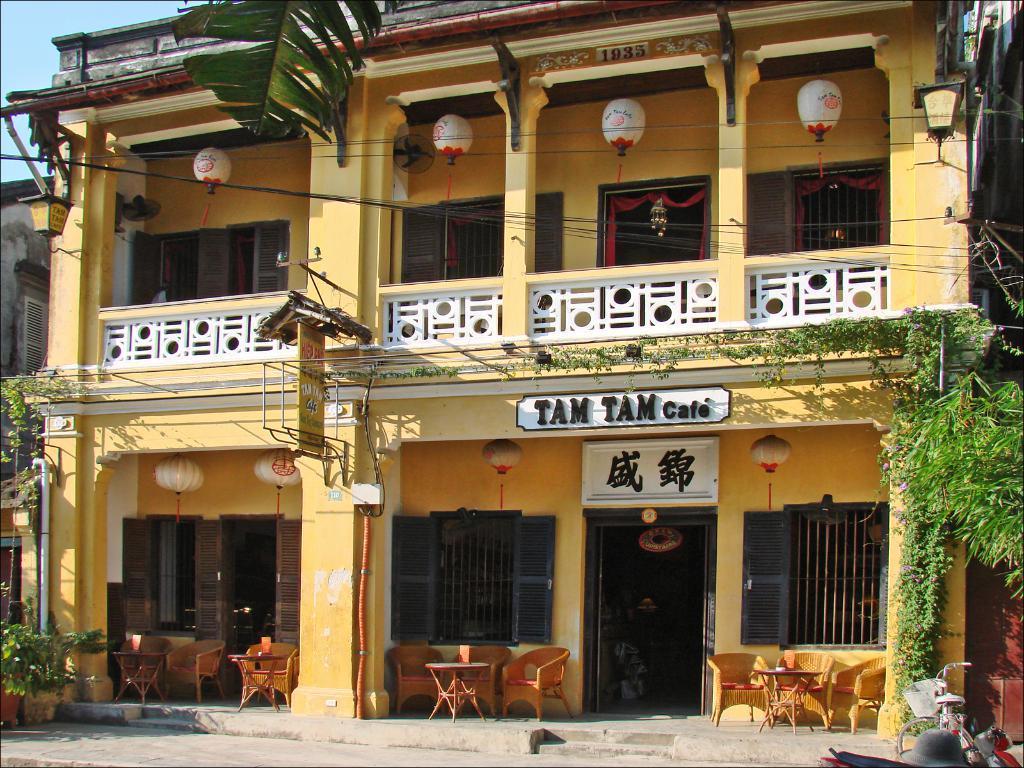In one or two sentences, can you explain what this image depicts? In the image we can see the building, fence, windows and the door. We can even see there are chairs and tables. Here we can see the lanterns, leaves and the door. Here we can see electric wires and the sky. 